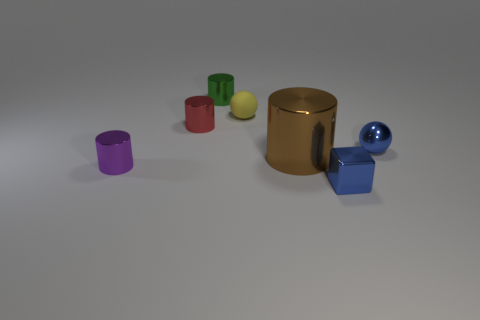Subtract all green cubes. Subtract all cyan spheres. How many cubes are left? 1 Add 2 large brown metal cylinders. How many objects exist? 9 Subtract all cylinders. How many objects are left? 3 Subtract 0 green balls. How many objects are left? 7 Subtract all brown shiny spheres. Subtract all red cylinders. How many objects are left? 6 Add 1 small rubber balls. How many small rubber balls are left? 2 Add 5 rubber objects. How many rubber objects exist? 6 